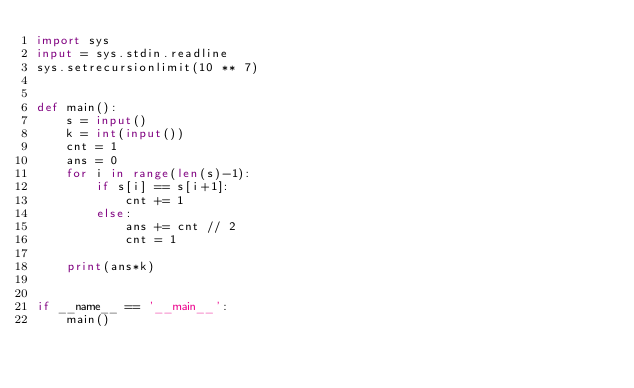<code> <loc_0><loc_0><loc_500><loc_500><_Python_>import sys
input = sys.stdin.readline
sys.setrecursionlimit(10 ** 7)


def main():
    s = input()
    k = int(input())
    cnt = 1
    ans = 0
    for i in range(len(s)-1):
        if s[i] == s[i+1]:
            cnt += 1
        else:
            ans += cnt // 2
            cnt = 1

    print(ans*k)


if __name__ == '__main__':
    main()
</code> 